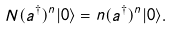<formula> <loc_0><loc_0><loc_500><loc_500>N ( a ^ { \dagger } ) ^ { n } | 0 \rangle = n ( a ^ { \dagger } ) ^ { n } | 0 \rangle .</formula> 